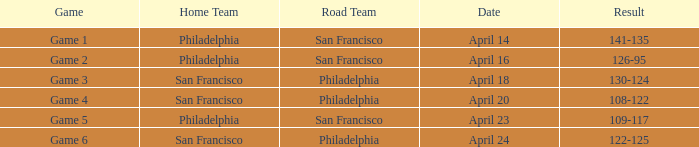Which game had a result of 126-95? Game 2. Write the full table. {'header': ['Game', 'Home Team', 'Road Team', 'Date', 'Result'], 'rows': [['Game 1', 'Philadelphia', 'San Francisco', 'April 14', '141-135'], ['Game 2', 'Philadelphia', 'San Francisco', 'April 16', '126-95'], ['Game 3', 'San Francisco', 'Philadelphia', 'April 18', '130-124'], ['Game 4', 'San Francisco', 'Philadelphia', 'April 20', '108-122'], ['Game 5', 'Philadelphia', 'San Francisco', 'April 23', '109-117'], ['Game 6', 'San Francisco', 'Philadelphia', 'April 24', '122-125']]} 